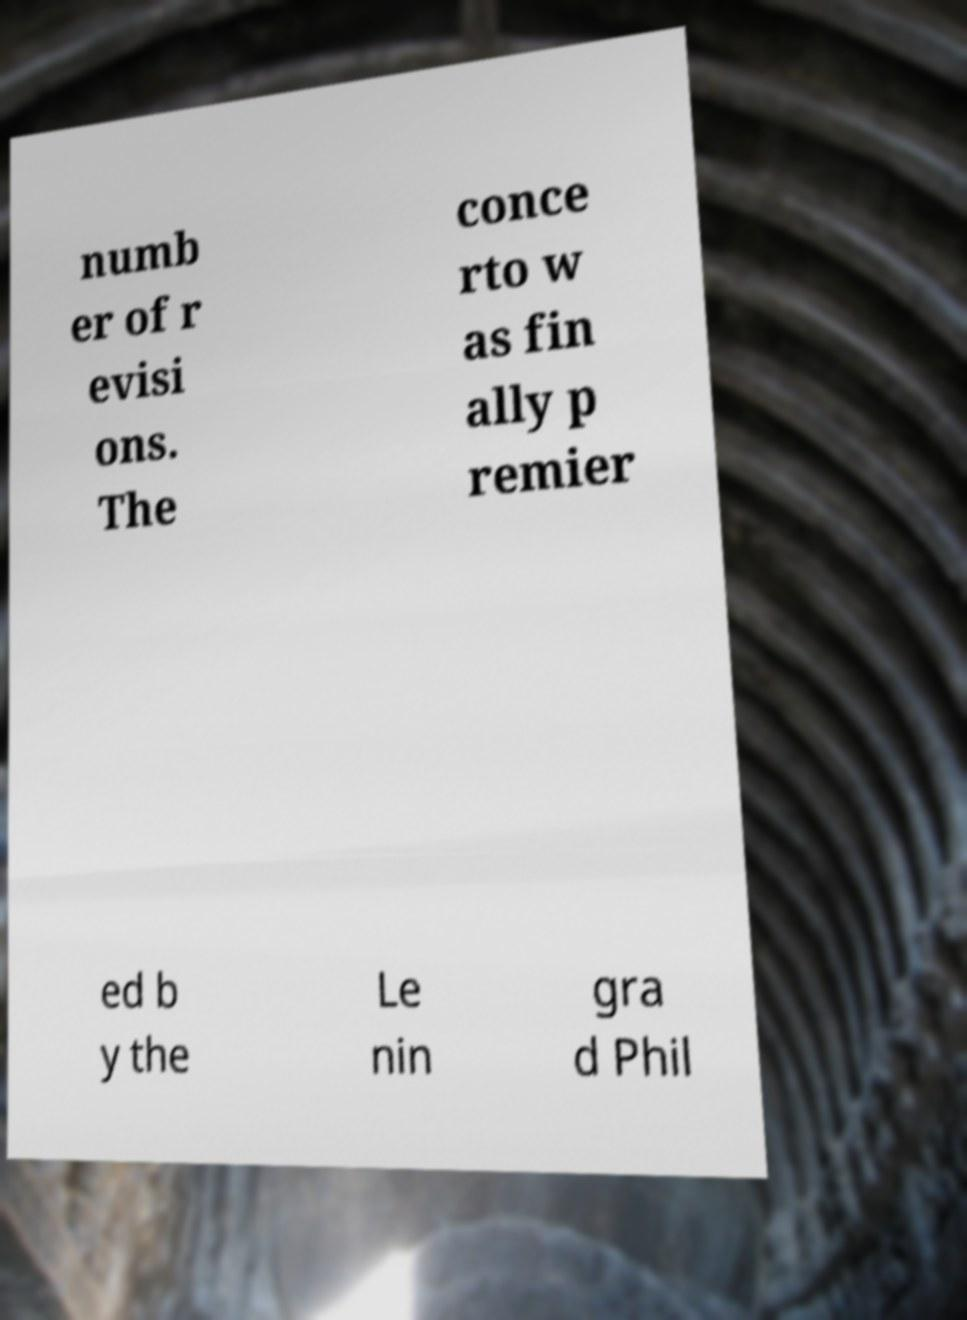For documentation purposes, I need the text within this image transcribed. Could you provide that? numb er of r evisi ons. The conce rto w as fin ally p remier ed b y the Le nin gra d Phil 